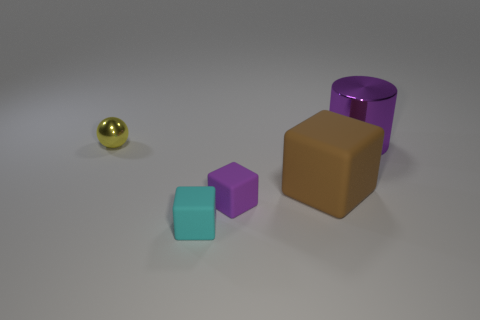What size is the matte object that is the same color as the big shiny thing?
Offer a very short reply. Small. Is the shape of the small purple rubber thing the same as the big thing left of the metallic cylinder?
Your answer should be very brief. Yes. The metal thing that is the same size as the brown cube is what color?
Offer a terse response. Purple. Are there fewer metal balls to the left of the small yellow object than metal things on the right side of the brown rubber block?
Your response must be concise. Yes. The metal thing left of the metallic thing that is behind the metal thing that is on the left side of the brown cube is what shape?
Your answer should be compact. Sphere. There is a large object behind the big brown matte cube; does it have the same color as the tiny object that is on the right side of the cyan matte cube?
Provide a short and direct response. Yes. The object that is the same color as the metallic cylinder is what shape?
Give a very brief answer. Cube. What number of matte things are big blocks or large cyan things?
Make the answer very short. 1. There is a shiny thing left of the rubber object on the left side of the small rubber cube behind the cyan matte cube; what is its color?
Offer a terse response. Yellow. There is a big thing that is the same shape as the tiny cyan object; what is its color?
Provide a succinct answer. Brown. 